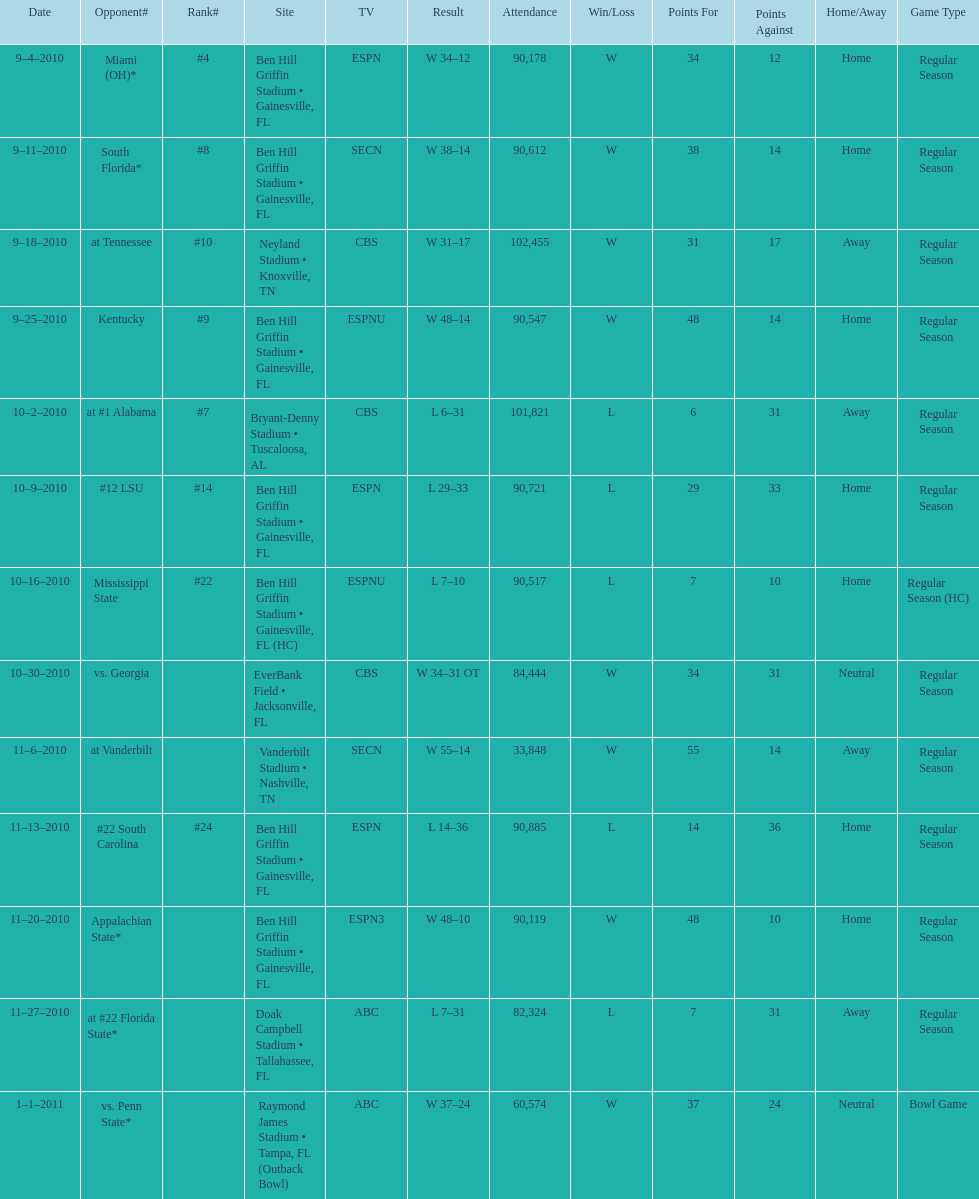What tv network showed the largest number of games during the 2010/2011 season? ESPN. 